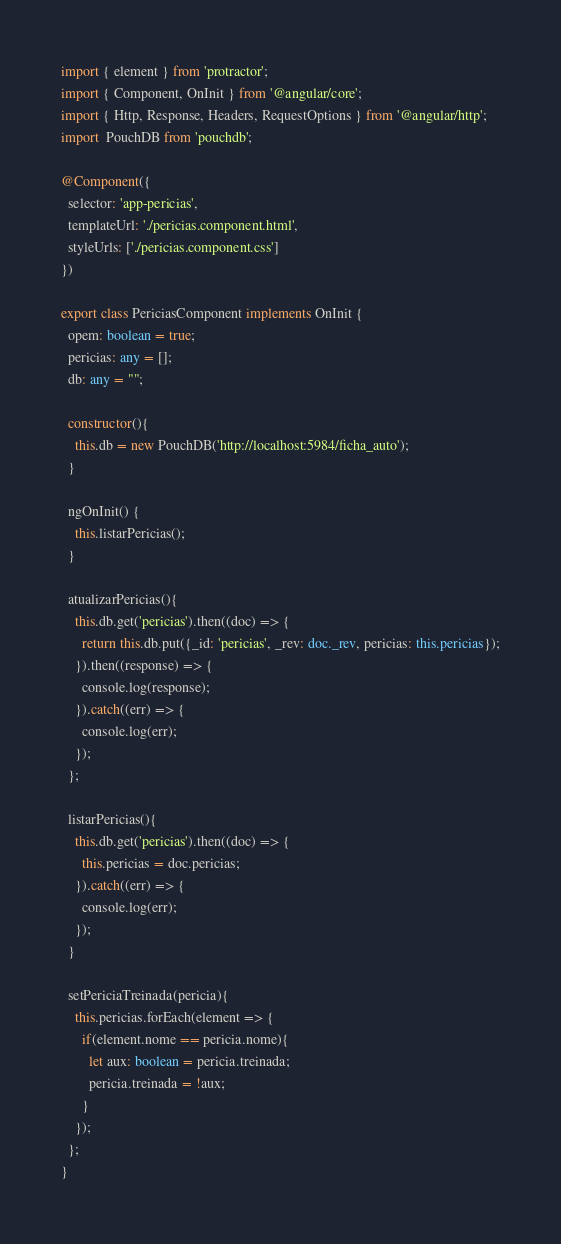<code> <loc_0><loc_0><loc_500><loc_500><_TypeScript_>import { element } from 'protractor';
import { Component, OnInit } from '@angular/core';
import { Http, Response, Headers, RequestOptions } from '@angular/http';
import  PouchDB from 'pouchdb';

@Component({
  selector: 'app-pericias',
  templateUrl: './pericias.component.html',
  styleUrls: ['./pericias.component.css']
})

export class PericiasComponent implements OnInit {
  opem: boolean = true;
  pericias: any = [];
  db: any = "";

  constructor(){
    this.db = new PouchDB('http://localhost:5984/ficha_auto');
  }

  ngOnInit() {
    this.listarPericias();
  }

  atualizarPericias(){
    this.db.get('pericias').then((doc) => {
      return this.db.put({_id: 'pericias', _rev: doc._rev, pericias: this.pericias});
    }).then((response) => {
      console.log(response);
    }).catch((err) => {
      console.log(err);
    });
  };

  listarPericias(){
    this.db.get('pericias').then((doc) => {
      this.pericias = doc.pericias;
    }).catch((err) => {
      console.log(err);
    });
  }

  setPericiaTreinada(pericia){
    this.pericias.forEach(element => {
      if(element.nome == pericia.nome){
        let aux: boolean = pericia.treinada;
        pericia.treinada = !aux;
      }
    });
  };  
}
</code> 